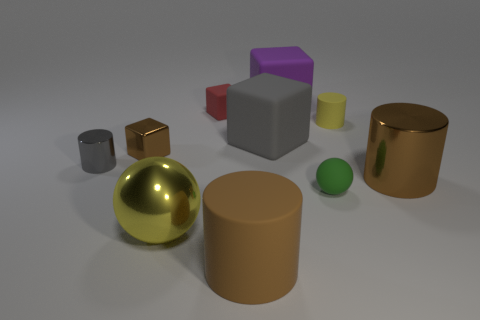Subtract all rubber blocks. How many blocks are left? 1 Add 1 big gray objects. How many big gray objects exist? 2 Subtract all purple blocks. How many blocks are left? 3 Subtract 2 brown cylinders. How many objects are left? 8 Subtract all cylinders. How many objects are left? 6 Subtract 1 cylinders. How many cylinders are left? 3 Subtract all red cylinders. Subtract all purple spheres. How many cylinders are left? 4 Subtract all brown blocks. How many green cylinders are left? 0 Subtract all small brown rubber things. Subtract all small brown metallic objects. How many objects are left? 9 Add 8 brown shiny cubes. How many brown shiny cubes are left? 9 